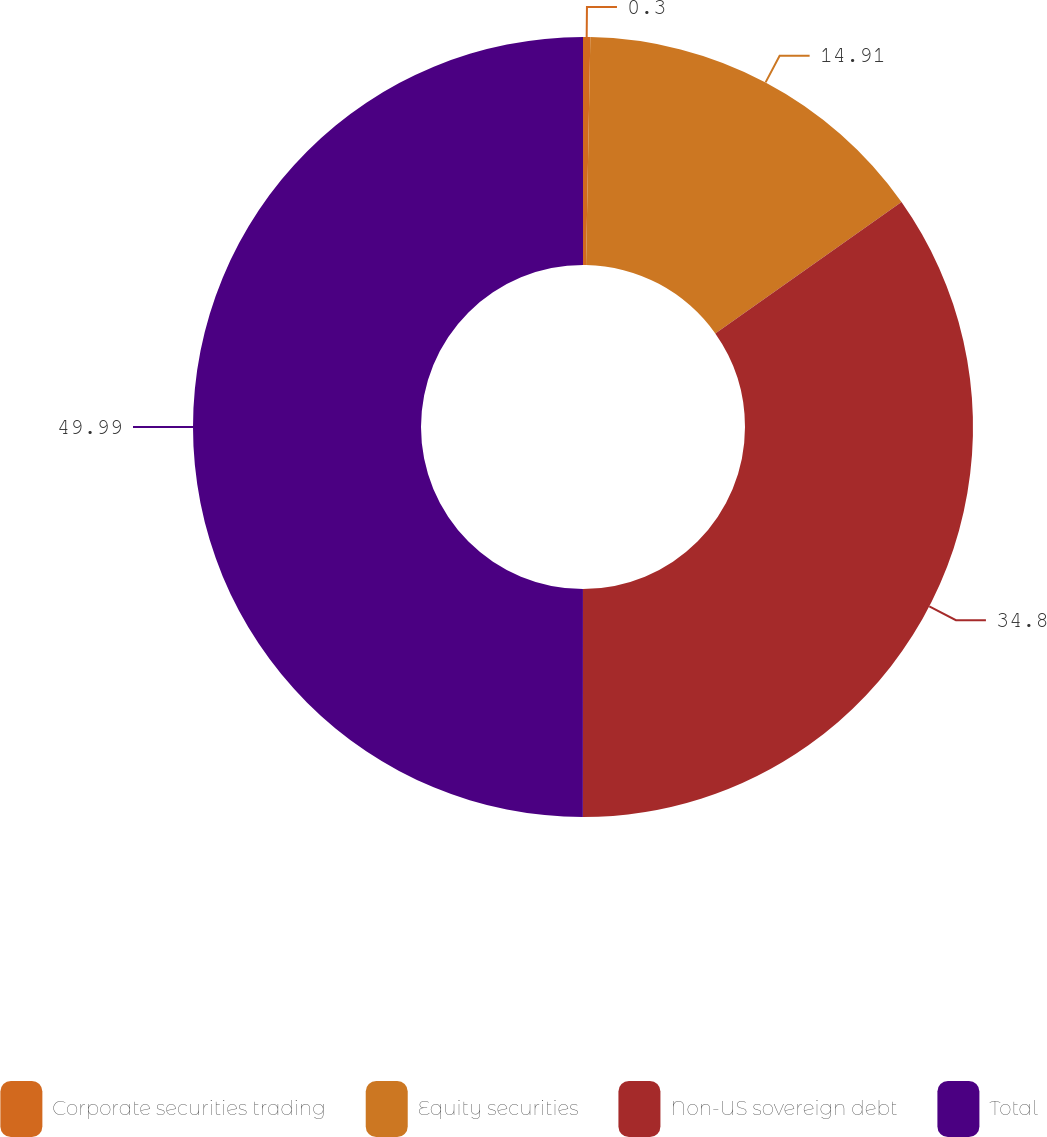<chart> <loc_0><loc_0><loc_500><loc_500><pie_chart><fcel>Corporate securities trading<fcel>Equity securities<fcel>Non-US sovereign debt<fcel>Total<nl><fcel>0.3%<fcel>14.91%<fcel>34.8%<fcel>50.0%<nl></chart> 